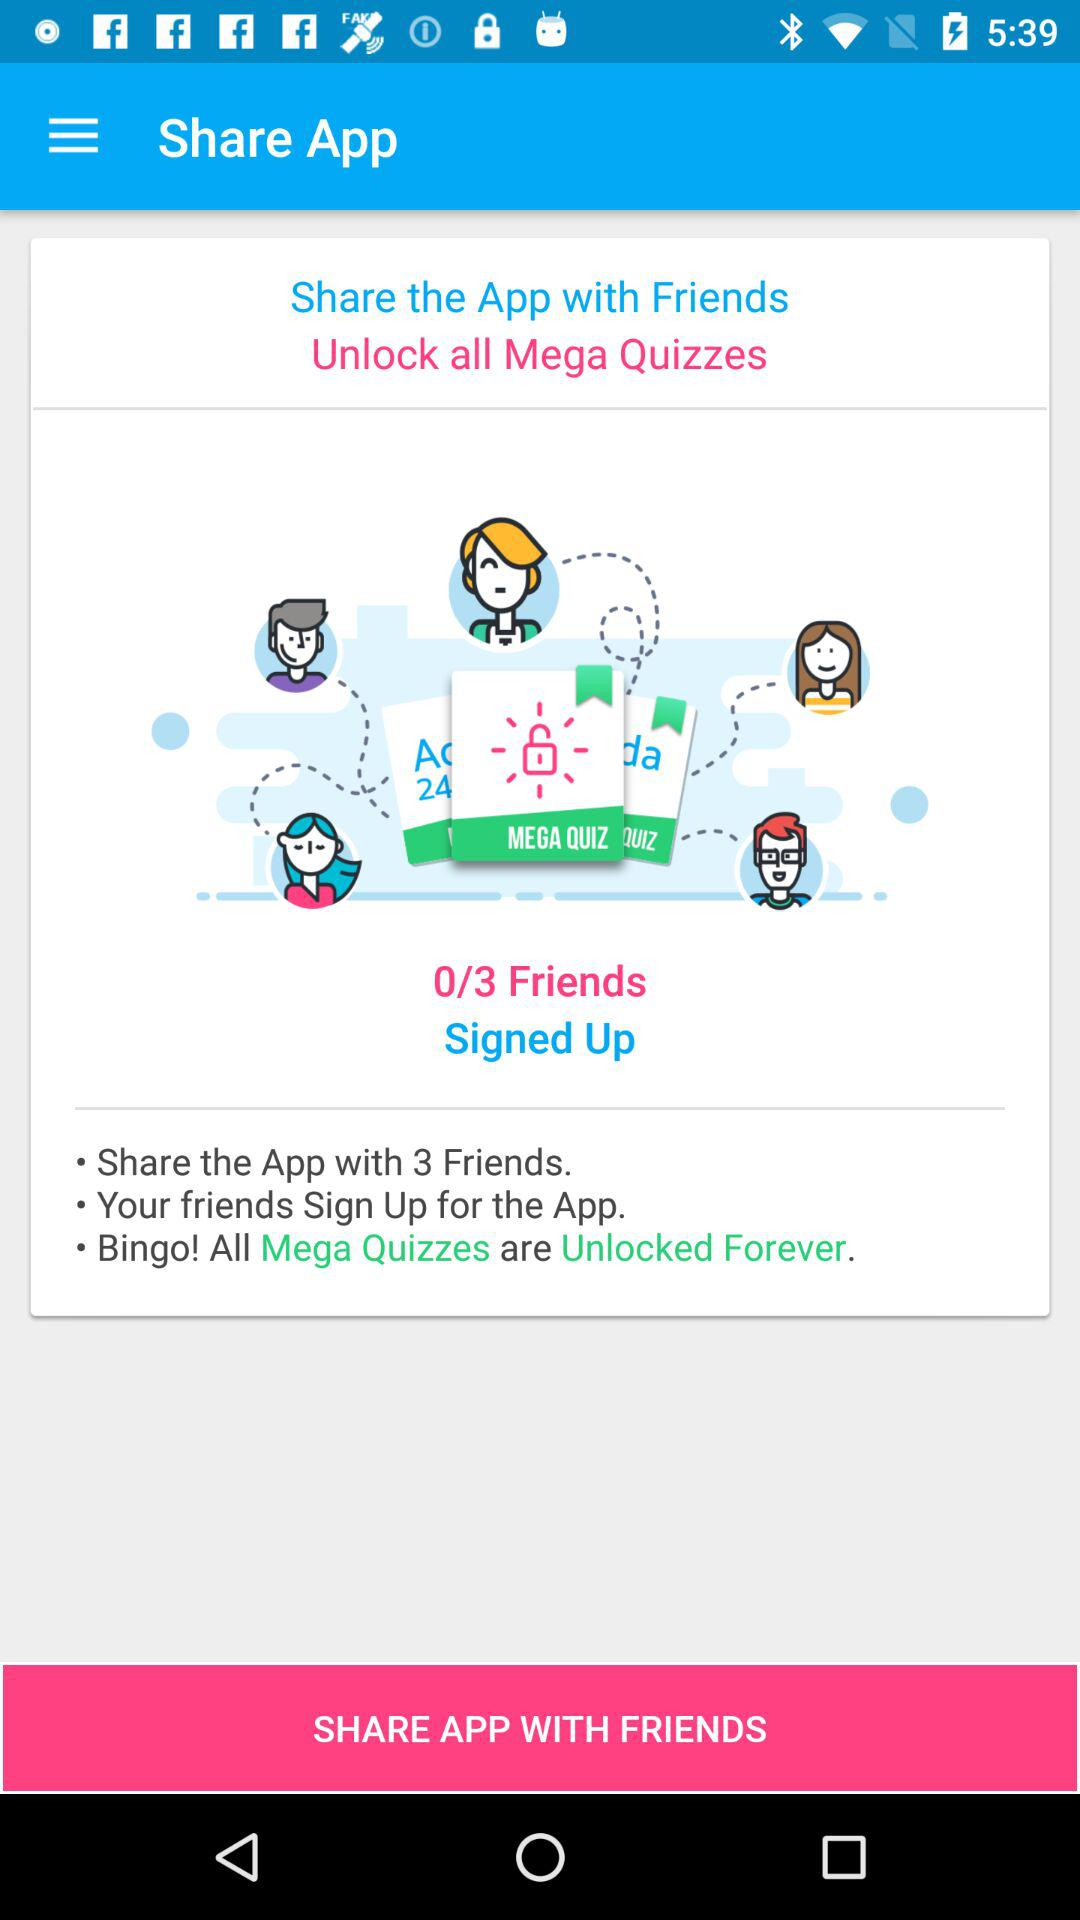To unlock all Mega Quizzes we have to share this app with how many friends? To unlock all Mega Quizzes, you have to share this app with 3 friends. 